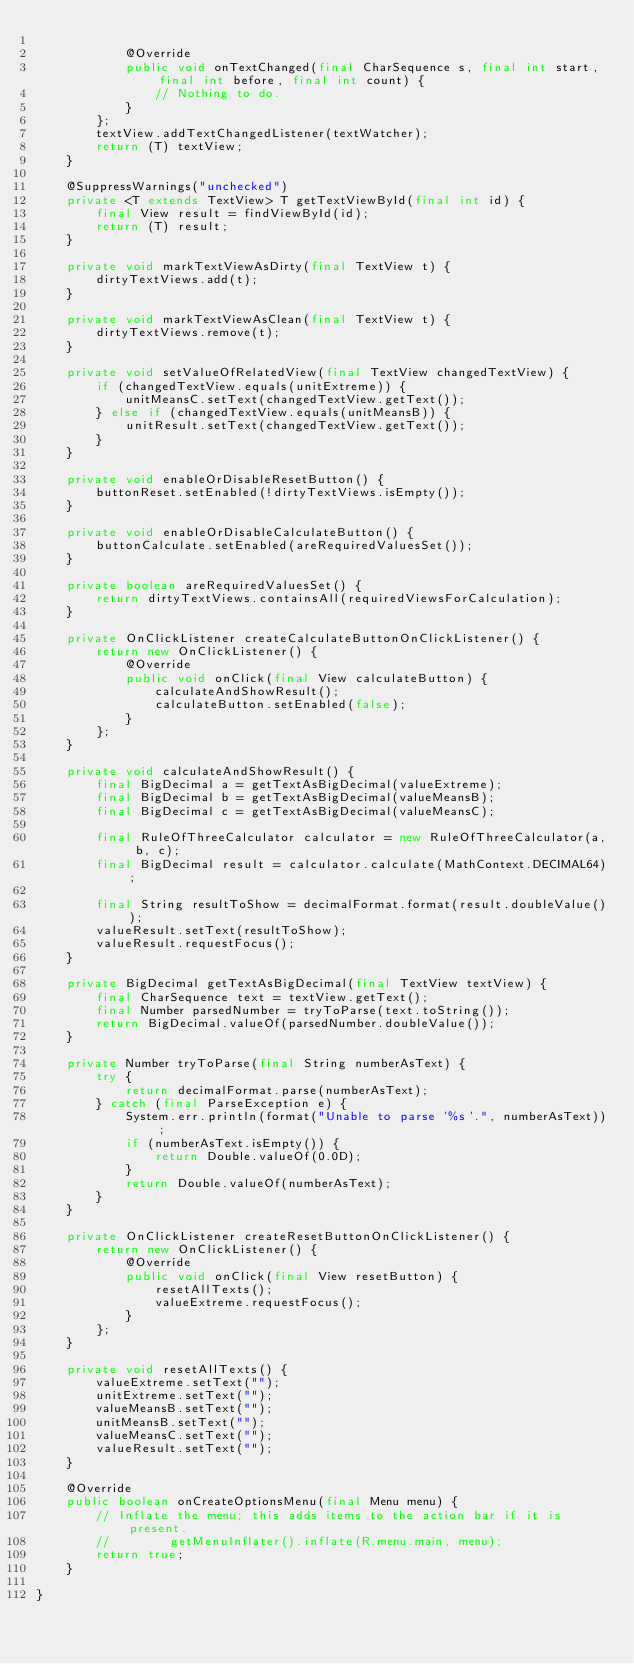Convert code to text. <code><loc_0><loc_0><loc_500><loc_500><_Java_>
            @Override
            public void onTextChanged(final CharSequence s, final int start, final int before, final int count) {
                // Nothing to do.
            }
        };
        textView.addTextChangedListener(textWatcher);
        return (T) textView;
    }

    @SuppressWarnings("unchecked")
    private <T extends TextView> T getTextViewById(final int id) {
        final View result = findViewById(id);
        return (T) result;
    }

    private void markTextViewAsDirty(final TextView t) {
        dirtyTextViews.add(t);
    }

    private void markTextViewAsClean(final TextView t) {
        dirtyTextViews.remove(t);
    }

    private void setValueOfRelatedView(final TextView changedTextView) {
        if (changedTextView.equals(unitExtreme)) {
            unitMeansC.setText(changedTextView.getText());
        } else if (changedTextView.equals(unitMeansB)) {
            unitResult.setText(changedTextView.getText());
        }
    }

    private void enableOrDisableResetButton() {
        buttonReset.setEnabled(!dirtyTextViews.isEmpty());
    }

    private void enableOrDisableCalculateButton() {
        buttonCalculate.setEnabled(areRequiredValuesSet());
    }

    private boolean areRequiredValuesSet() {
        return dirtyTextViews.containsAll(requiredViewsForCalculation);
    }

    private OnClickListener createCalculateButtonOnClickListener() {
        return new OnClickListener() {
            @Override
            public void onClick(final View calculateButton) {
                calculateAndShowResult();
                calculateButton.setEnabled(false);
            }
        };
    }

    private void calculateAndShowResult() {
        final BigDecimal a = getTextAsBigDecimal(valueExtreme);
        final BigDecimal b = getTextAsBigDecimal(valueMeansB);
        final BigDecimal c = getTextAsBigDecimal(valueMeansC);

        final RuleOfThreeCalculator calculator = new RuleOfThreeCalculator(a, b, c);
        final BigDecimal result = calculator.calculate(MathContext.DECIMAL64);

        final String resultToShow = decimalFormat.format(result.doubleValue());
        valueResult.setText(resultToShow);
        valueResult.requestFocus();
    }

    private BigDecimal getTextAsBigDecimal(final TextView textView) {
        final CharSequence text = textView.getText();
        final Number parsedNumber = tryToParse(text.toString());
        return BigDecimal.valueOf(parsedNumber.doubleValue());
    }

    private Number tryToParse(final String numberAsText) {
        try {
            return decimalFormat.parse(numberAsText);
        } catch (final ParseException e) {
            System.err.println(format("Unable to parse '%s'.", numberAsText));
            if (numberAsText.isEmpty()) {
                return Double.valueOf(0.0D);
            }
            return Double.valueOf(numberAsText);
        }
    }

    private OnClickListener createResetButtonOnClickListener() {
        return new OnClickListener() {
            @Override
            public void onClick(final View resetButton) {
                resetAllTexts();
                valueExtreme.requestFocus();
            }
        };
    }

    private void resetAllTexts() {
        valueExtreme.setText("");
        unitExtreme.setText("");
        valueMeansB.setText("");
        unitMeansB.setText("");
        valueMeansC.setText("");
        valueResult.setText("");
    }

    @Override
    public boolean onCreateOptionsMenu(final Menu menu) {
        // Inflate the menu; this adds items to the action bar if it is present.
        //        getMenuInflater().inflate(R.menu.main, menu);
        return true;
    }

}
</code> 